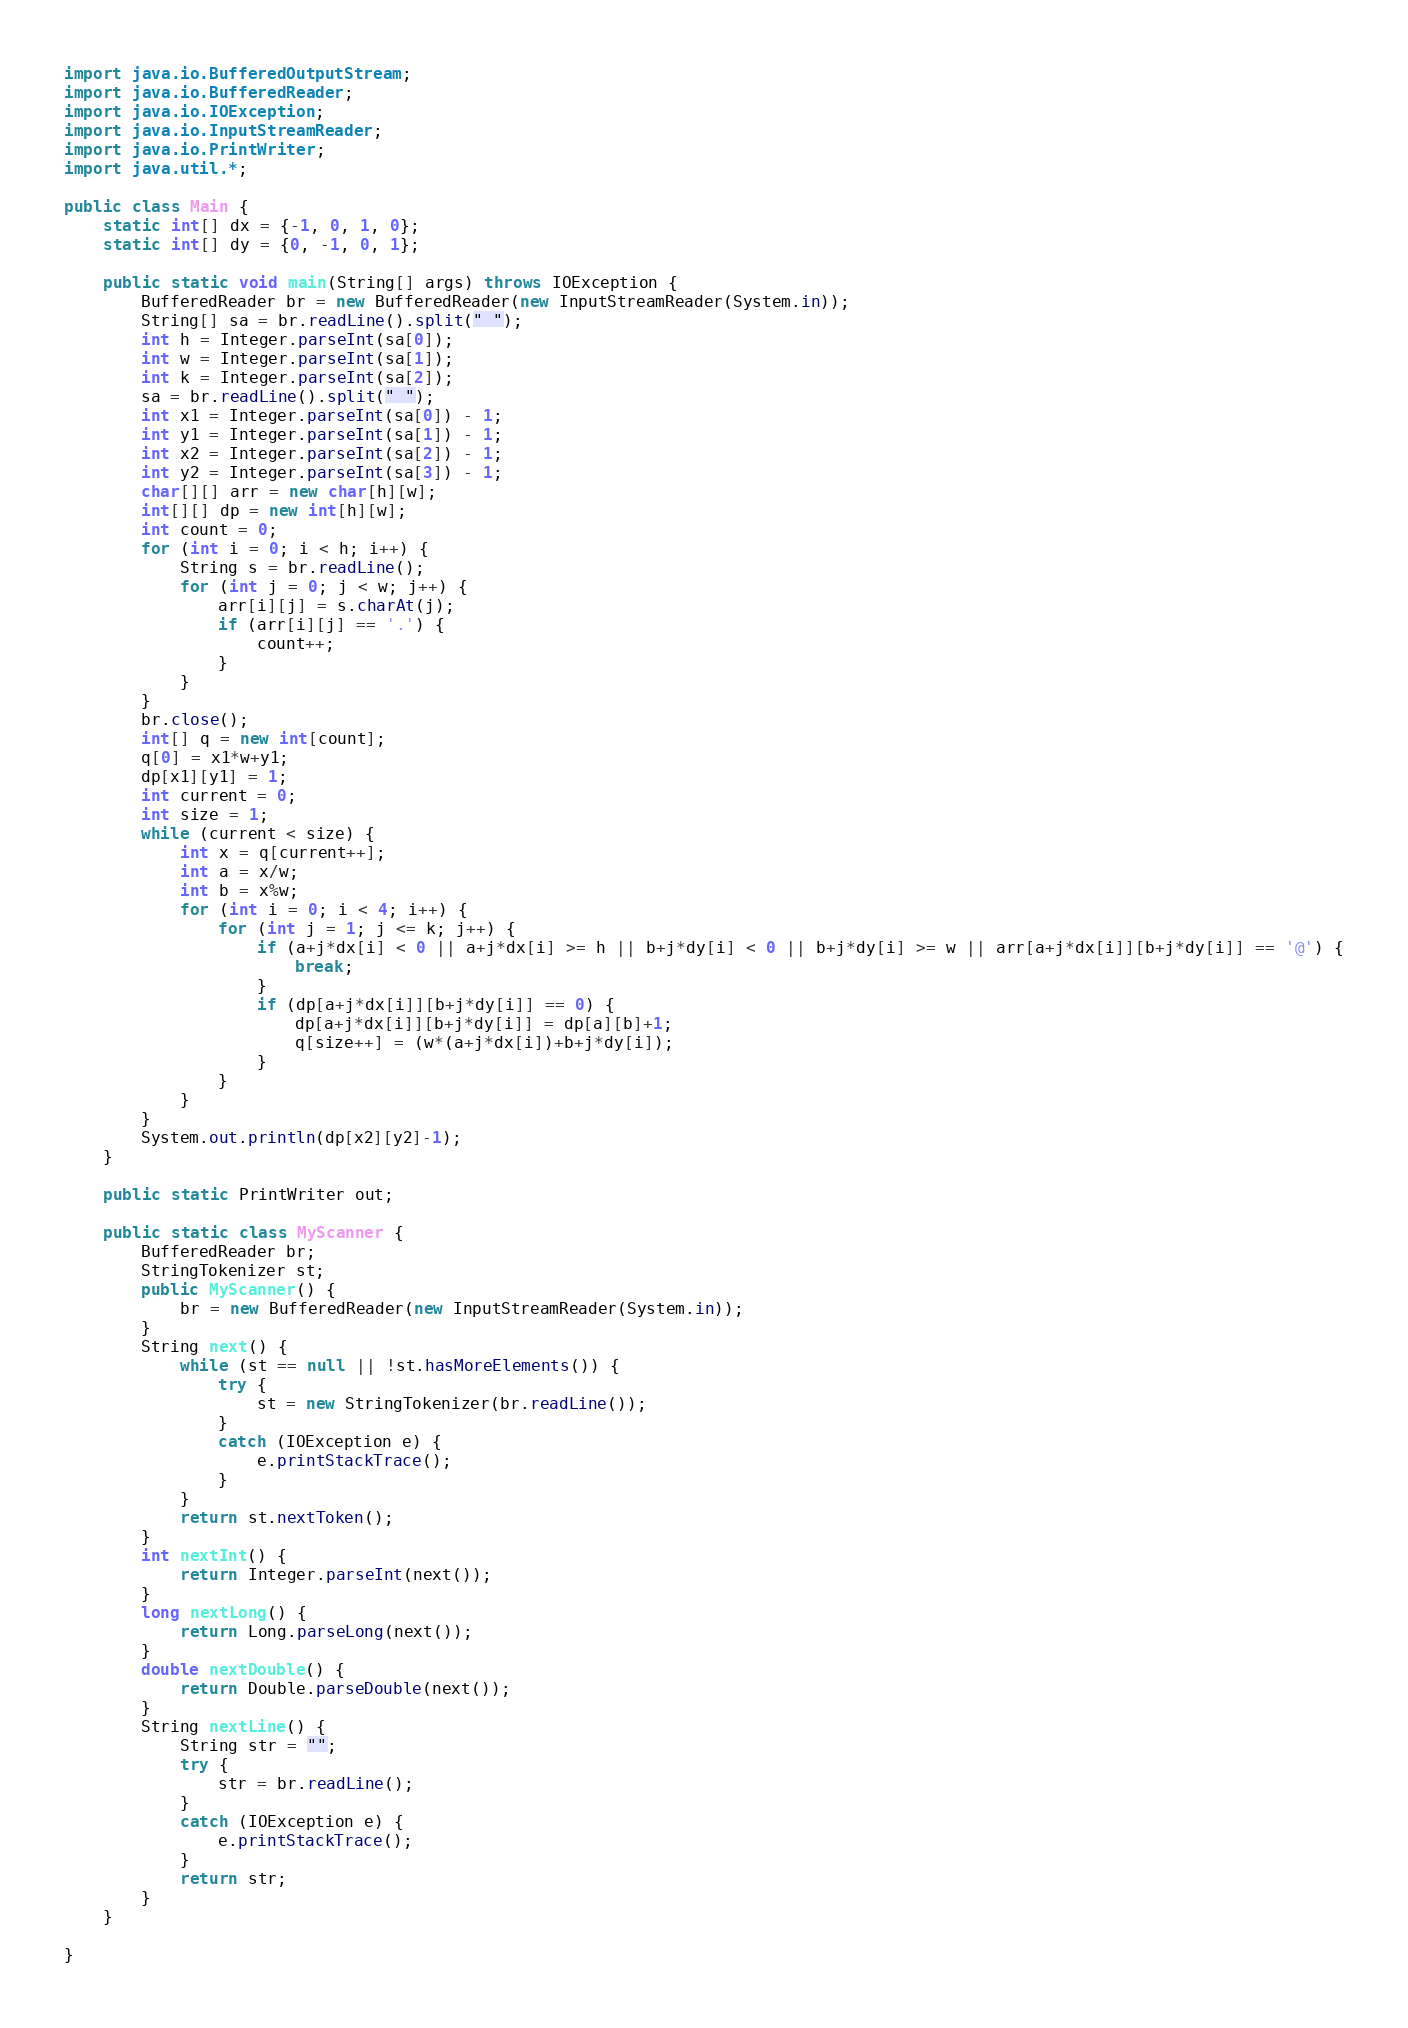Convert code to text. <code><loc_0><loc_0><loc_500><loc_500><_Java_>import java.io.BufferedOutputStream;
import java.io.BufferedReader;
import java.io.IOException;
import java.io.InputStreamReader;
import java.io.PrintWriter;
import java.util.*;

public class Main {
	static int[] dx = {-1, 0, 1, 0};
	static int[] dy = {0, -1, 0, 1};

	public static void main(String[] args) throws IOException {
		BufferedReader br = new BufferedReader(new InputStreamReader(System.in));
		String[] sa = br.readLine().split(" ");
		int h = Integer.parseInt(sa[0]);
		int w = Integer.parseInt(sa[1]);
		int k = Integer.parseInt(sa[2]);
		sa = br.readLine().split(" ");
		int x1 = Integer.parseInt(sa[0]) - 1;
		int y1 = Integer.parseInt(sa[1]) - 1;
		int x2 = Integer.parseInt(sa[2]) - 1;
		int y2 = Integer.parseInt(sa[3]) - 1;
		char[][] arr = new char[h][w];
		int[][] dp = new int[h][w];
		int count = 0;
		for (int i = 0; i < h; i++) {
			String s = br.readLine();
			for (int j = 0; j < w; j++) {
				arr[i][j] = s.charAt(j);
				if (arr[i][j] == '.') {
					count++;
				}
			}
		}
		br.close();
		int[] q = new int[count];
		q[0] = x1*w+y1;
		dp[x1][y1] = 1;
		int current = 0;
		int size = 1;
		while (current < size) {
			int x = q[current++];
			int a = x/w;
			int b = x%w;
			for (int i = 0; i < 4; i++) {
				for (int j = 1; j <= k; j++) {
					if (a+j*dx[i] < 0 || a+j*dx[i] >= h || b+j*dy[i] < 0 || b+j*dy[i] >= w || arr[a+j*dx[i]][b+j*dy[i]] == '@') {
						break;
					}
					if (dp[a+j*dx[i]][b+j*dy[i]] == 0) {
						dp[a+j*dx[i]][b+j*dy[i]] = dp[a][b]+1;
						q[size++] = (w*(a+j*dx[i])+b+j*dy[i]);
					}
				}
			}
		}
		System.out.println(dp[x2][y2]-1);
	}
	
	public static PrintWriter out;
	
	public static class MyScanner {
		BufferedReader br;
		StringTokenizer st;
		public MyScanner() {
			br = new BufferedReader(new InputStreamReader(System.in));
		}
		String next() {
			while (st == null || !st.hasMoreElements()) {
				try {
					st = new StringTokenizer(br.readLine());
				}
				catch (IOException e) {
					e.printStackTrace();
				}
			}
			return st.nextToken();
		}
		int nextInt() {
			return Integer.parseInt(next());
		}
		long nextLong() {
			return Long.parseLong(next());
		}
		double nextDouble() {
			return Double.parseDouble(next());
		}
		String nextLine() {
			String str = "";
			try {
				str = br.readLine();
			}
			catch (IOException e) {
				e.printStackTrace();
			}
			return str;
		}
	}

}
</code> 